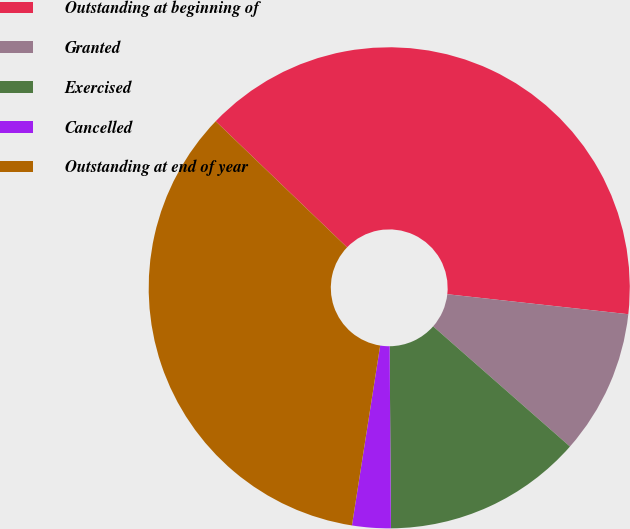<chart> <loc_0><loc_0><loc_500><loc_500><pie_chart><fcel>Outstanding at beginning of<fcel>Granted<fcel>Exercised<fcel>Cancelled<fcel>Outstanding at end of year<nl><fcel>39.58%<fcel>9.72%<fcel>13.42%<fcel>2.59%<fcel>34.7%<nl></chart> 